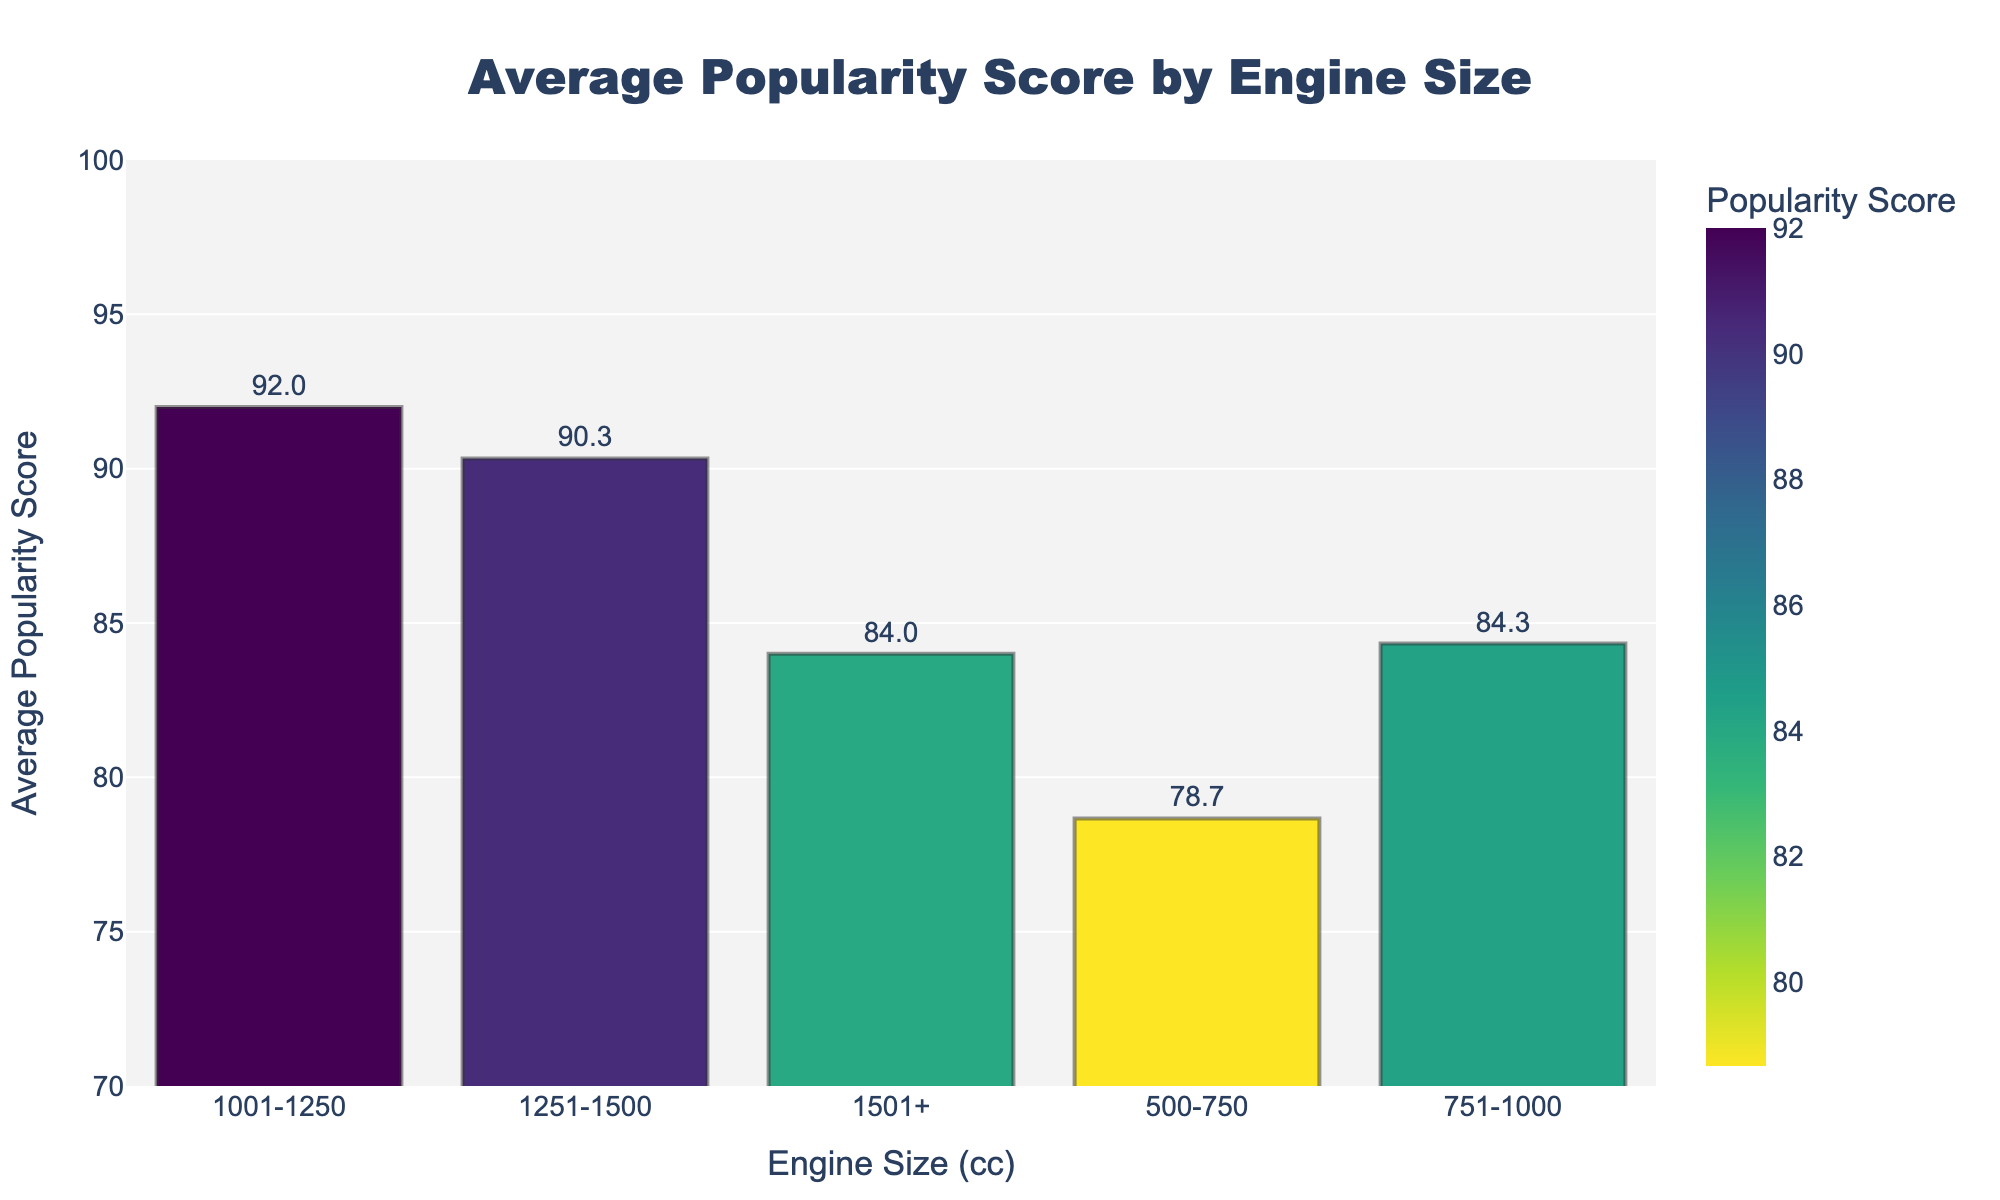Which engine size has the highest average popularity score? To determine the engine size with the highest average popularity score, refer to the bar representing the highest value on the y-axis. The bar for the "1001-1250 cc" engine size has the highest popularity score.
Answer: 1001-1250 cc Which engine size category has the lowest average popularity score? Look at the bar with the lowest height on the y-axis. The "500-750 cc" engine size category has the lowest average popularity score.
Answer: 500-750 cc How much higher is the average popularity score of the 1001-1250 cc category compared to the 751-1000 cc category? Identify the average popularity scores for both categories from the figure. Subtract the score of the 751-1000 cc category from the 1001-1250 cc category: 92 - 84.3.
Answer: 7.7 Which engine size categories have an average popularity score of 90 or higher? Check the bars that meet or exceed the 90 mark on the y-axis. The categories "1001-1250 cc" and "1251-1500 cc" have average popularity scores that are 90 or higher.
Answer: 1001-1250 cc, 1251-1500 cc What is the average popularity score difference between the 1501+ cc and 500-750 cc categories? Determine the scores from the bars, then find the difference: 84 - 78.7.
Answer: 5.3 Which engine size categories scored higher than 80 on average? Identify bars that surpass the 80 mark on the y-axis. The categories "751-1000 cc," "1001-1250 cc," "1251-1500 cc," and "1501+ cc" scored higher than 80 on average.
Answer: 751-1000 cc, 1001-1250 cc, 1251-1500 cc, 1501+ cc Compare the average popularity scores of the 500-750 cc and 1251-1500 cc categories. Which one is higher and by how much? Look at the heights of the bars for these two categories. The 1251-1500 cc category bar is higher. Calculate the difference: 91 - 78.7.
Answer: 1251-1500 cc by 12.3 What is the combined average popularity score of the 500-750 cc and 751-1000 cc categories? Sum the average popularity scores of these two categories: 78.7 + 84.3.
Answer: 163 Among the engine size categories that have an average popularity score above 85, which one has the lowest score? First, filter the categories with scores above 85: "1001-1250 cc", "1251-1500 cc", and "751-1000 cc". The "751-1000 cc" category has the lowest score among them.
Answer: 751-1000 cc How does the average popularity score of the 1501+ cc category compare to the overall highest score? Identify the highest score, which is from the 1001-1250 cc category (92), and compare it to the 1501+ cc category score (84). Calculate the difference: 92 - 84.
Answer: 8 lower 